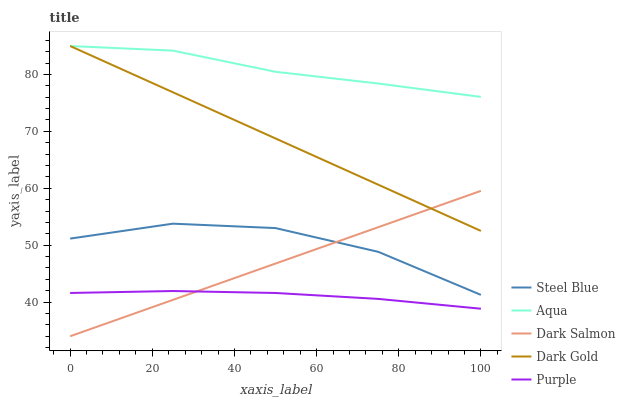Does Dark Gold have the minimum area under the curve?
Answer yes or no. No. Does Dark Gold have the maximum area under the curve?
Answer yes or no. No. Is Dark Gold the smoothest?
Answer yes or no. No. Is Dark Gold the roughest?
Answer yes or no. No. Does Dark Gold have the lowest value?
Answer yes or no. No. Does Steel Blue have the highest value?
Answer yes or no. No. Is Purple less than Dark Gold?
Answer yes or no. Yes. Is Aqua greater than Steel Blue?
Answer yes or no. Yes. Does Purple intersect Dark Gold?
Answer yes or no. No. 